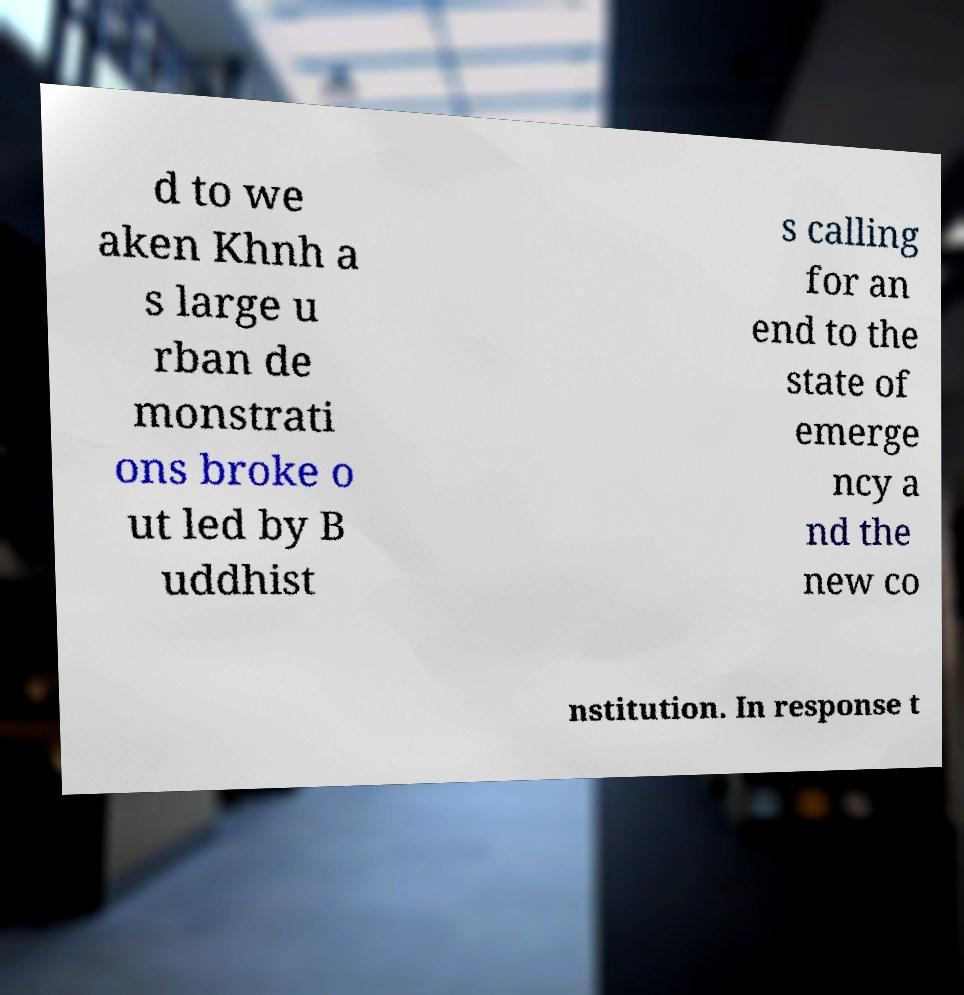Could you extract and type out the text from this image? d to we aken Khnh a s large u rban de monstrati ons broke o ut led by B uddhist s calling for an end to the state of emerge ncy a nd the new co nstitution. In response t 